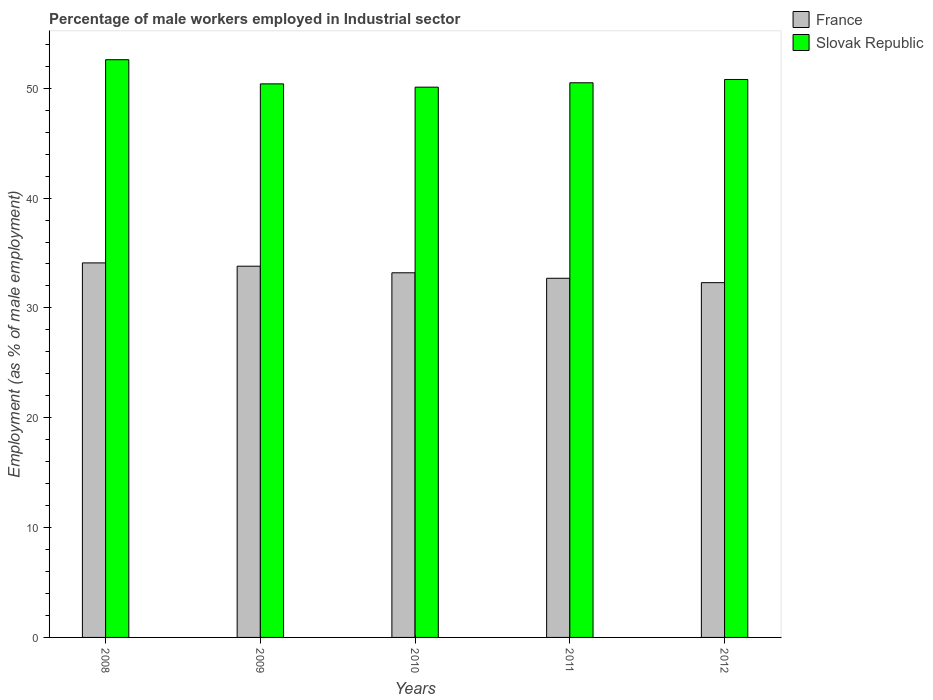How many different coloured bars are there?
Your response must be concise. 2. How many groups of bars are there?
Your answer should be very brief. 5. Are the number of bars per tick equal to the number of legend labels?
Your answer should be compact. Yes. Are the number of bars on each tick of the X-axis equal?
Give a very brief answer. Yes. How many bars are there on the 2nd tick from the left?
Give a very brief answer. 2. What is the label of the 1st group of bars from the left?
Provide a short and direct response. 2008. What is the percentage of male workers employed in Industrial sector in France in 2010?
Your response must be concise. 33.2. Across all years, what is the maximum percentage of male workers employed in Industrial sector in Slovak Republic?
Ensure brevity in your answer.  52.6. Across all years, what is the minimum percentage of male workers employed in Industrial sector in France?
Provide a short and direct response. 32.3. What is the total percentage of male workers employed in Industrial sector in Slovak Republic in the graph?
Ensure brevity in your answer.  254.4. What is the difference between the percentage of male workers employed in Industrial sector in Slovak Republic in 2008 and that in 2012?
Make the answer very short. 1.8. What is the difference between the percentage of male workers employed in Industrial sector in France in 2010 and the percentage of male workers employed in Industrial sector in Slovak Republic in 2012?
Provide a succinct answer. -17.6. What is the average percentage of male workers employed in Industrial sector in France per year?
Offer a terse response. 33.22. In the year 2008, what is the difference between the percentage of male workers employed in Industrial sector in Slovak Republic and percentage of male workers employed in Industrial sector in France?
Keep it short and to the point. 18.5. In how many years, is the percentage of male workers employed in Industrial sector in France greater than 16 %?
Ensure brevity in your answer.  5. What is the ratio of the percentage of male workers employed in Industrial sector in Slovak Republic in 2010 to that in 2012?
Your answer should be compact. 0.99. Is the difference between the percentage of male workers employed in Industrial sector in Slovak Republic in 2008 and 2009 greater than the difference between the percentage of male workers employed in Industrial sector in France in 2008 and 2009?
Provide a short and direct response. Yes. What is the difference between the highest and the second highest percentage of male workers employed in Industrial sector in Slovak Republic?
Your answer should be compact. 1.8. What does the 2nd bar from the left in 2009 represents?
Provide a succinct answer. Slovak Republic. What does the 2nd bar from the right in 2010 represents?
Ensure brevity in your answer.  France. How many bars are there?
Provide a succinct answer. 10. Are all the bars in the graph horizontal?
Your response must be concise. No. How many years are there in the graph?
Your response must be concise. 5. What is the difference between two consecutive major ticks on the Y-axis?
Keep it short and to the point. 10. Are the values on the major ticks of Y-axis written in scientific E-notation?
Ensure brevity in your answer.  No. Where does the legend appear in the graph?
Give a very brief answer. Top right. What is the title of the graph?
Ensure brevity in your answer.  Percentage of male workers employed in Industrial sector. Does "Iran" appear as one of the legend labels in the graph?
Your response must be concise. No. What is the label or title of the Y-axis?
Provide a short and direct response. Employment (as % of male employment). What is the Employment (as % of male employment) of France in 2008?
Provide a succinct answer. 34.1. What is the Employment (as % of male employment) of Slovak Republic in 2008?
Give a very brief answer. 52.6. What is the Employment (as % of male employment) of France in 2009?
Keep it short and to the point. 33.8. What is the Employment (as % of male employment) in Slovak Republic in 2009?
Make the answer very short. 50.4. What is the Employment (as % of male employment) in France in 2010?
Your answer should be compact. 33.2. What is the Employment (as % of male employment) in Slovak Republic in 2010?
Provide a succinct answer. 50.1. What is the Employment (as % of male employment) of France in 2011?
Offer a very short reply. 32.7. What is the Employment (as % of male employment) of Slovak Republic in 2011?
Offer a very short reply. 50.5. What is the Employment (as % of male employment) of France in 2012?
Keep it short and to the point. 32.3. What is the Employment (as % of male employment) in Slovak Republic in 2012?
Provide a succinct answer. 50.8. Across all years, what is the maximum Employment (as % of male employment) in France?
Your response must be concise. 34.1. Across all years, what is the maximum Employment (as % of male employment) of Slovak Republic?
Offer a terse response. 52.6. Across all years, what is the minimum Employment (as % of male employment) in France?
Your response must be concise. 32.3. Across all years, what is the minimum Employment (as % of male employment) in Slovak Republic?
Your answer should be very brief. 50.1. What is the total Employment (as % of male employment) in France in the graph?
Your answer should be compact. 166.1. What is the total Employment (as % of male employment) in Slovak Republic in the graph?
Offer a very short reply. 254.4. What is the difference between the Employment (as % of male employment) in France in 2008 and that in 2009?
Your answer should be compact. 0.3. What is the difference between the Employment (as % of male employment) of Slovak Republic in 2008 and that in 2009?
Provide a succinct answer. 2.2. What is the difference between the Employment (as % of male employment) in Slovak Republic in 2008 and that in 2011?
Keep it short and to the point. 2.1. What is the difference between the Employment (as % of male employment) in Slovak Republic in 2009 and that in 2010?
Your answer should be very brief. 0.3. What is the difference between the Employment (as % of male employment) in France in 2009 and that in 2011?
Make the answer very short. 1.1. What is the difference between the Employment (as % of male employment) in France in 2009 and that in 2012?
Your answer should be compact. 1.5. What is the difference between the Employment (as % of male employment) of Slovak Republic in 2009 and that in 2012?
Offer a terse response. -0.4. What is the difference between the Employment (as % of male employment) in France in 2010 and that in 2011?
Provide a short and direct response. 0.5. What is the difference between the Employment (as % of male employment) in Slovak Republic in 2010 and that in 2011?
Your answer should be compact. -0.4. What is the difference between the Employment (as % of male employment) in Slovak Republic in 2010 and that in 2012?
Offer a terse response. -0.7. What is the difference between the Employment (as % of male employment) of France in 2008 and the Employment (as % of male employment) of Slovak Republic in 2009?
Make the answer very short. -16.3. What is the difference between the Employment (as % of male employment) in France in 2008 and the Employment (as % of male employment) in Slovak Republic in 2011?
Your response must be concise. -16.4. What is the difference between the Employment (as % of male employment) in France in 2008 and the Employment (as % of male employment) in Slovak Republic in 2012?
Your answer should be very brief. -16.7. What is the difference between the Employment (as % of male employment) in France in 2009 and the Employment (as % of male employment) in Slovak Republic in 2010?
Your answer should be compact. -16.3. What is the difference between the Employment (as % of male employment) in France in 2009 and the Employment (as % of male employment) in Slovak Republic in 2011?
Ensure brevity in your answer.  -16.7. What is the difference between the Employment (as % of male employment) in France in 2010 and the Employment (as % of male employment) in Slovak Republic in 2011?
Offer a very short reply. -17.3. What is the difference between the Employment (as % of male employment) in France in 2010 and the Employment (as % of male employment) in Slovak Republic in 2012?
Offer a very short reply. -17.6. What is the difference between the Employment (as % of male employment) of France in 2011 and the Employment (as % of male employment) of Slovak Republic in 2012?
Your response must be concise. -18.1. What is the average Employment (as % of male employment) in France per year?
Offer a very short reply. 33.22. What is the average Employment (as % of male employment) of Slovak Republic per year?
Provide a short and direct response. 50.88. In the year 2008, what is the difference between the Employment (as % of male employment) of France and Employment (as % of male employment) of Slovak Republic?
Give a very brief answer. -18.5. In the year 2009, what is the difference between the Employment (as % of male employment) in France and Employment (as % of male employment) in Slovak Republic?
Your response must be concise. -16.6. In the year 2010, what is the difference between the Employment (as % of male employment) in France and Employment (as % of male employment) in Slovak Republic?
Ensure brevity in your answer.  -16.9. In the year 2011, what is the difference between the Employment (as % of male employment) in France and Employment (as % of male employment) in Slovak Republic?
Offer a terse response. -17.8. In the year 2012, what is the difference between the Employment (as % of male employment) of France and Employment (as % of male employment) of Slovak Republic?
Offer a very short reply. -18.5. What is the ratio of the Employment (as % of male employment) in France in 2008 to that in 2009?
Your response must be concise. 1.01. What is the ratio of the Employment (as % of male employment) in Slovak Republic in 2008 to that in 2009?
Your answer should be very brief. 1.04. What is the ratio of the Employment (as % of male employment) of France in 2008 to that in 2010?
Your answer should be compact. 1.03. What is the ratio of the Employment (as % of male employment) in Slovak Republic in 2008 to that in 2010?
Your response must be concise. 1.05. What is the ratio of the Employment (as % of male employment) of France in 2008 to that in 2011?
Offer a very short reply. 1.04. What is the ratio of the Employment (as % of male employment) of Slovak Republic in 2008 to that in 2011?
Keep it short and to the point. 1.04. What is the ratio of the Employment (as % of male employment) of France in 2008 to that in 2012?
Provide a succinct answer. 1.06. What is the ratio of the Employment (as % of male employment) of Slovak Republic in 2008 to that in 2012?
Ensure brevity in your answer.  1.04. What is the ratio of the Employment (as % of male employment) in France in 2009 to that in 2010?
Make the answer very short. 1.02. What is the ratio of the Employment (as % of male employment) in Slovak Republic in 2009 to that in 2010?
Your response must be concise. 1.01. What is the ratio of the Employment (as % of male employment) in France in 2009 to that in 2011?
Your response must be concise. 1.03. What is the ratio of the Employment (as % of male employment) of France in 2009 to that in 2012?
Your response must be concise. 1.05. What is the ratio of the Employment (as % of male employment) of France in 2010 to that in 2011?
Your answer should be very brief. 1.02. What is the ratio of the Employment (as % of male employment) of France in 2010 to that in 2012?
Your answer should be compact. 1.03. What is the ratio of the Employment (as % of male employment) in Slovak Republic in 2010 to that in 2012?
Provide a succinct answer. 0.99. What is the ratio of the Employment (as % of male employment) of France in 2011 to that in 2012?
Make the answer very short. 1.01. What is the difference between the highest and the second highest Employment (as % of male employment) in Slovak Republic?
Offer a terse response. 1.8. What is the difference between the highest and the lowest Employment (as % of male employment) of France?
Offer a terse response. 1.8. 